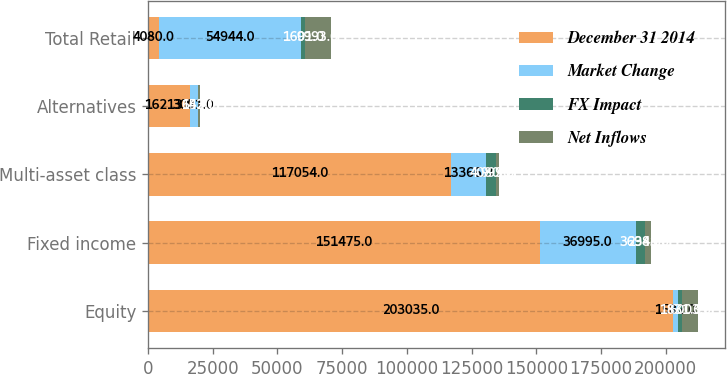Convert chart to OTSL. <chart><loc_0><loc_0><loc_500><loc_500><stacked_bar_chart><ecel><fcel>Equity<fcel>Fixed income<fcel>Multi-asset class<fcel>Alternatives<fcel>Total Retail<nl><fcel>December 31 2014<fcel>203035<fcel>151475<fcel>117054<fcel>16213<fcel>4080<nl><fcel>Market Change<fcel>1582<fcel>36995<fcel>13366<fcel>3001<fcel>54944<nl><fcel>FX Impact<fcel>1831<fcel>3698<fcel>4080<fcel>152<fcel>1601<nl><fcel>Net Inflows<fcel>6003<fcel>2348<fcel>999<fcel>643<fcel>9993<nl></chart> 